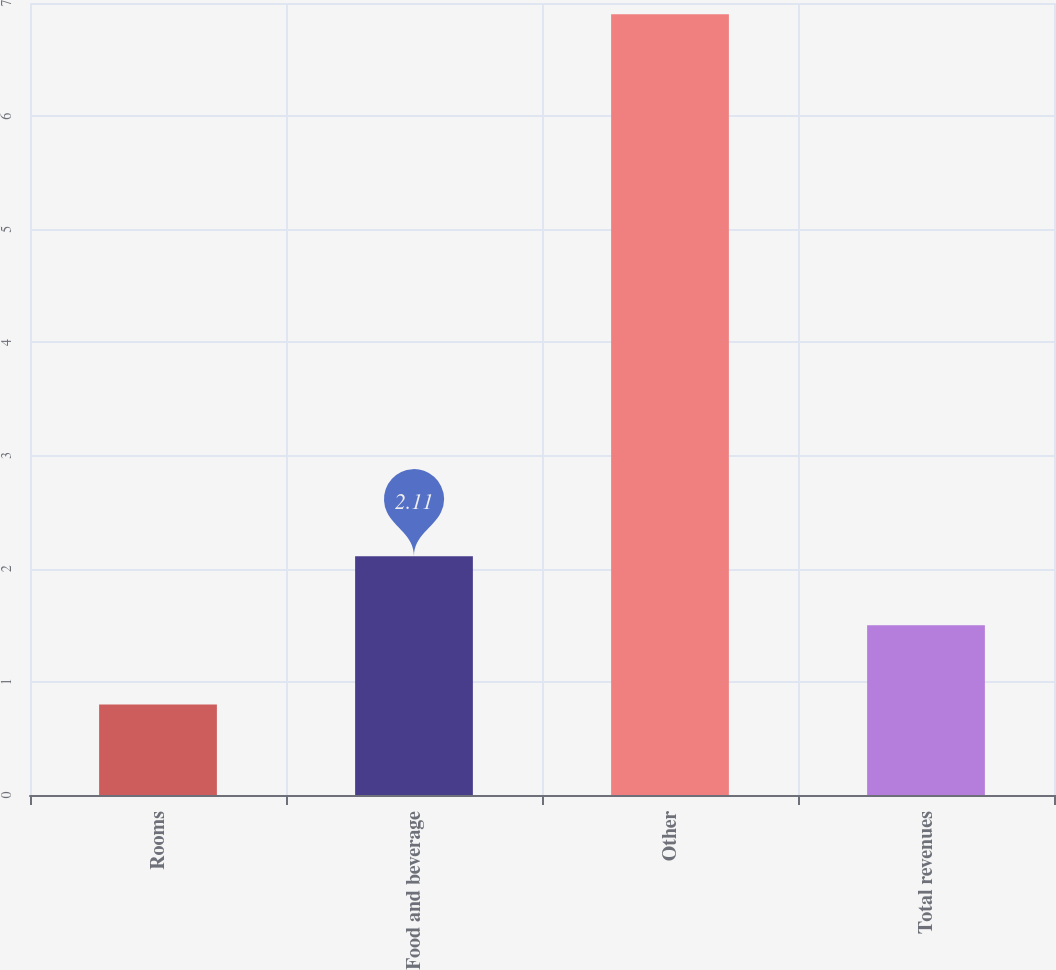<chart> <loc_0><loc_0><loc_500><loc_500><bar_chart><fcel>Rooms<fcel>Food and beverage<fcel>Other<fcel>Total revenues<nl><fcel>0.8<fcel>2.11<fcel>6.9<fcel>1.5<nl></chart> 